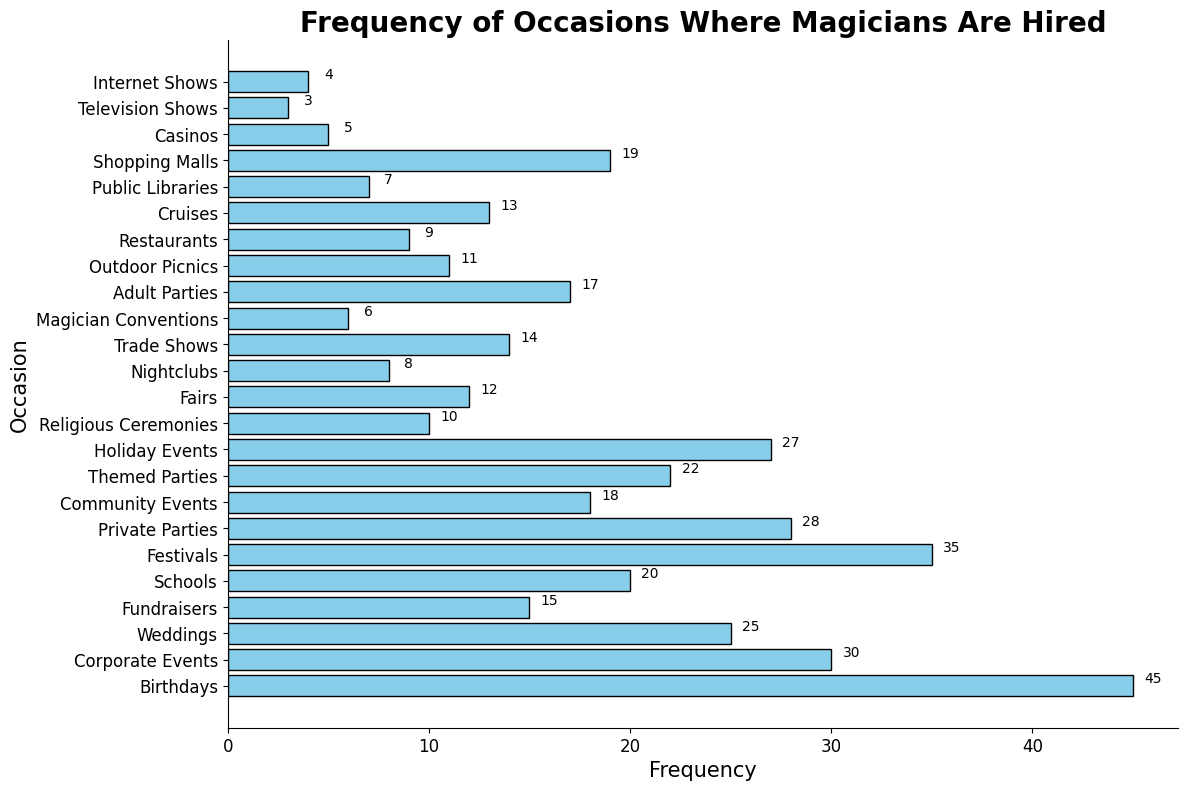What is the most common occasion where magicians are hired? Look for the bar with the greatest width in the histogram. The bar with the largest width is for "Birthdays," indicating that it is the most common occasion.
Answer: Birthdays Which has a higher frequency, Corporate Events or Weddings? Compare the widths of the bars for Corporate Events and Weddings. The Corporate Events bar is wider with a frequency of 30 compared to the Weddings bar with a frequency of 25.
Answer: Corporate Events How many more times are magicians hired for Festivals than for Nightclubs? First, find the frequency of both Festivals and Nightclubs from the histogram. Festivals have a frequency of 35, and Nightclubs have a frequency of 8. Subtract the frequency of Nightclubs from the frequency of Festivals: 35 - 8 = 27.
Answer: 27 Among Fairs, Trade Shows, and Outdoor Picnics, which occasion has the least frequency? Compare the bars corresponding to Fairs, Trade Shows, and Outdoor Picnics. The bar for Casinos has the smallest width, which is 5.
Answer: Trade Shows What is the total frequency of all occasions where magicians are hired for parties (Birthdays, Private Parties, Themed Parties, Adult Parties)? Find the frequencies for Birthdays (45), Private Parties (28), Themed Parties (22), and Adult Parties (17). Sum these frequencies: 45 + 28 + 22 + 17 = 112.
Answer: 112 Is the frequency of magicians hired for Internet Shows higher or lower than for Television Shows? Compare the frequencies of Internet Shows and Television Shows. Internet Shows have a frequency of 4, whereas Television Shows have a frequency of 3.
Answer: Higher What is the average frequency of hiring magicians for Religious Ceremonies, Cruises, and Restaurants? Find the frequencies of Religious Ceremonies (10), Cruises (13), and Restaurants (9). Calculate their sum and then divide by 3: (10 + 13 + 9) / 3 = 32 / 3 ≈ 10.67.
Answer: Approximately 10.67 How does the frequency of Community Events compare to Shopping Malls? Compare the widths of the bars for Community Events and Shopping Malls. The Community Events bar has a frequency of 18, while the Shopping Malls bar has a frequency of 19.
Answer: Less than Which occasion has a frequency of exactly 10? Look for the bar with a label on the y-axis corresponding to 10. The bar corresponding to Religious Ceremonies has a frequency of 10.
Answer: Religious Ceremonies 